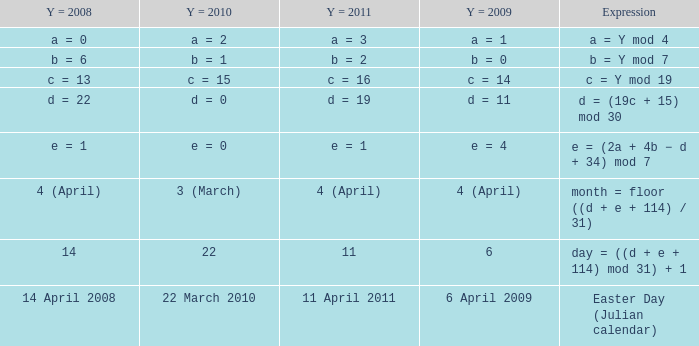What is the y = 2011 when the y = 2010  is 22 march 2010? 11 April 2011. 